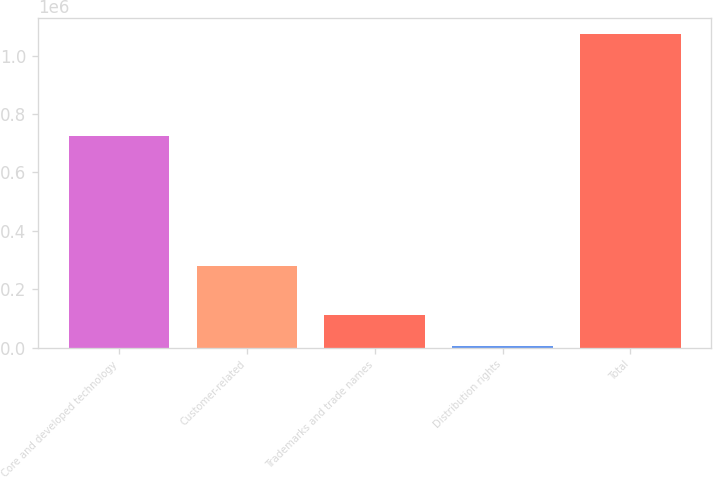Convert chart. <chart><loc_0><loc_0><loc_500><loc_500><bar_chart><fcel>Core and developed technology<fcel>Customer-related<fcel>Trademarks and trade names<fcel>Distribution rights<fcel>Total<nl><fcel>724883<fcel>278542<fcel>112523<fcel>5580<fcel>1.07501e+06<nl></chart> 